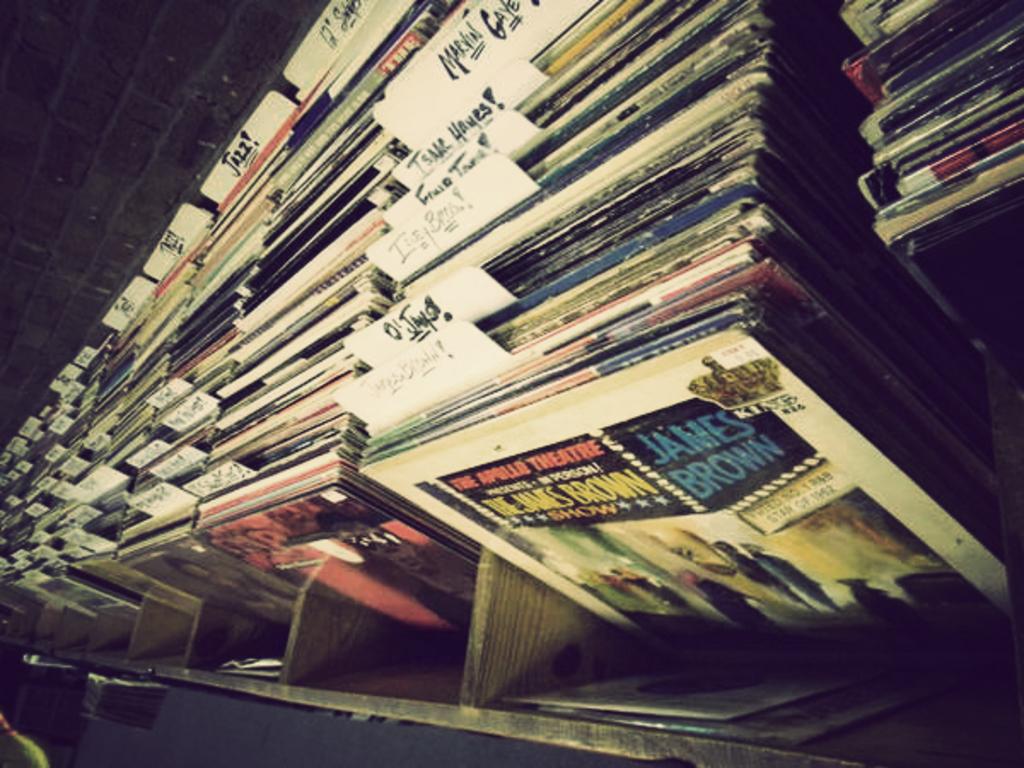What is the name of the theater?
Your response must be concise. The apollo. 